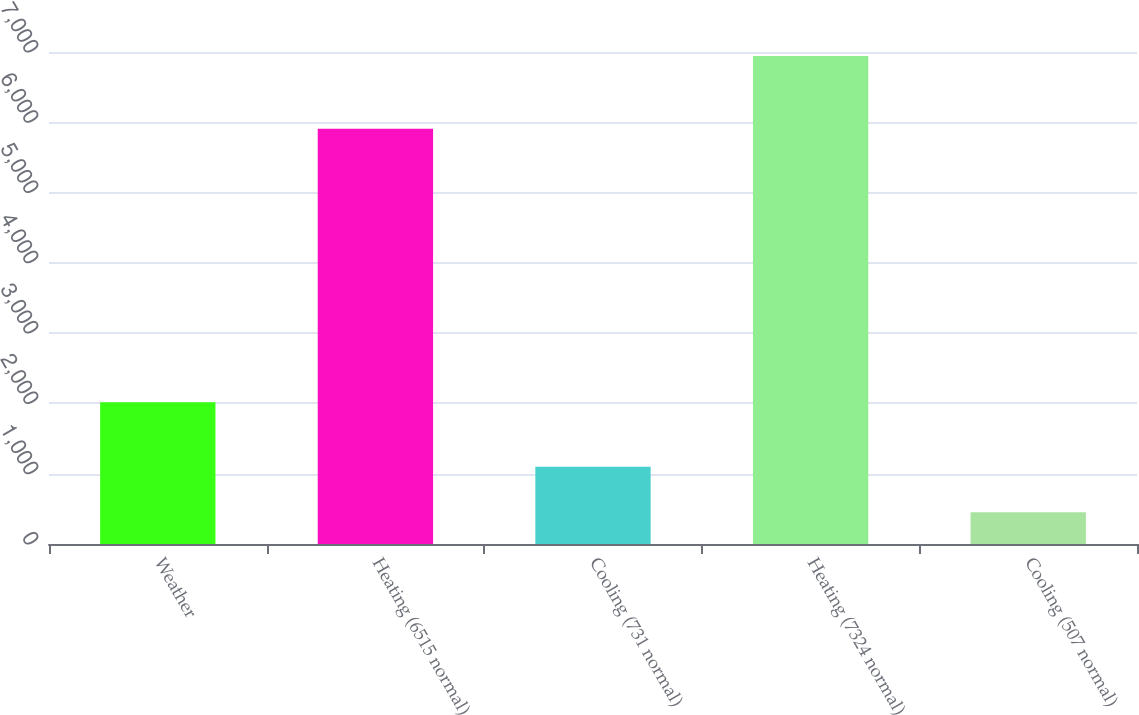Convert chart to OTSL. <chart><loc_0><loc_0><loc_500><loc_500><bar_chart><fcel>Weather<fcel>Heating (6515 normal)<fcel>Cooling (731 normal)<fcel>Heating (7324 normal)<fcel>Cooling (507 normal)<nl><fcel>2017<fcel>5908<fcel>1099.2<fcel>6942<fcel>450<nl></chart> 